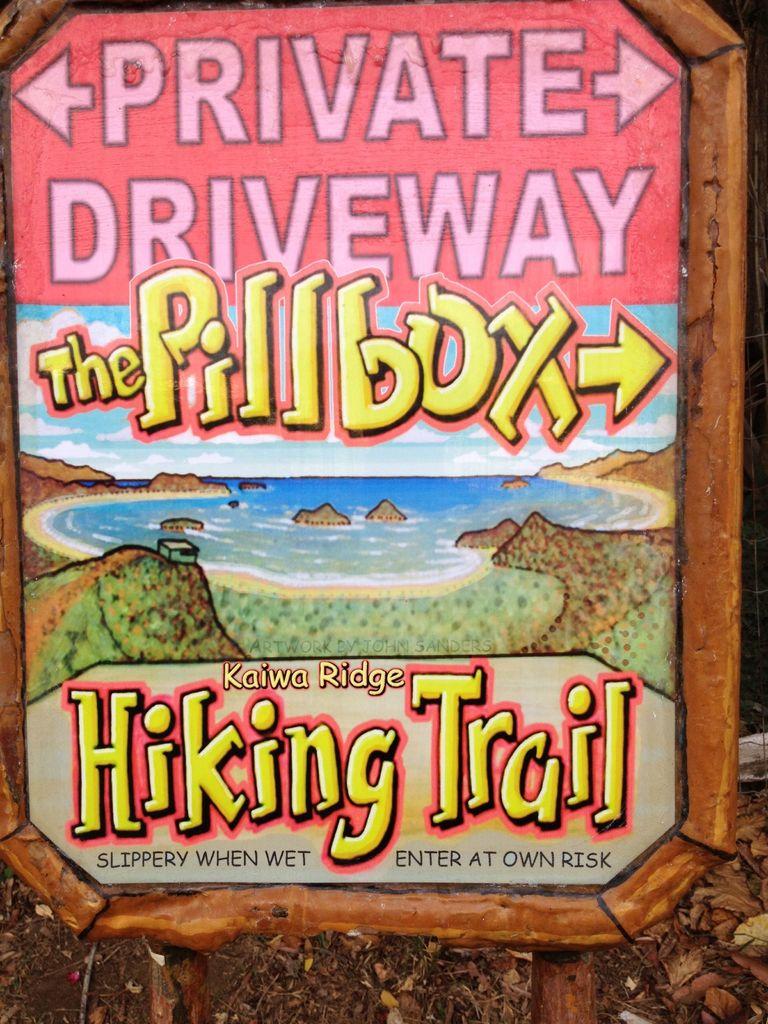What is slippery when wet?
Your response must be concise. Hiking trail. What does the very top word say?
Your response must be concise. Private. 